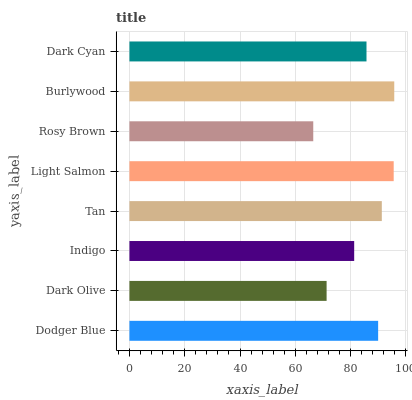Is Rosy Brown the minimum?
Answer yes or no. Yes. Is Burlywood the maximum?
Answer yes or no. Yes. Is Dark Olive the minimum?
Answer yes or no. No. Is Dark Olive the maximum?
Answer yes or no. No. Is Dodger Blue greater than Dark Olive?
Answer yes or no. Yes. Is Dark Olive less than Dodger Blue?
Answer yes or no. Yes. Is Dark Olive greater than Dodger Blue?
Answer yes or no. No. Is Dodger Blue less than Dark Olive?
Answer yes or no. No. Is Dodger Blue the high median?
Answer yes or no. Yes. Is Dark Cyan the low median?
Answer yes or no. Yes. Is Burlywood the high median?
Answer yes or no. No. Is Indigo the low median?
Answer yes or no. No. 